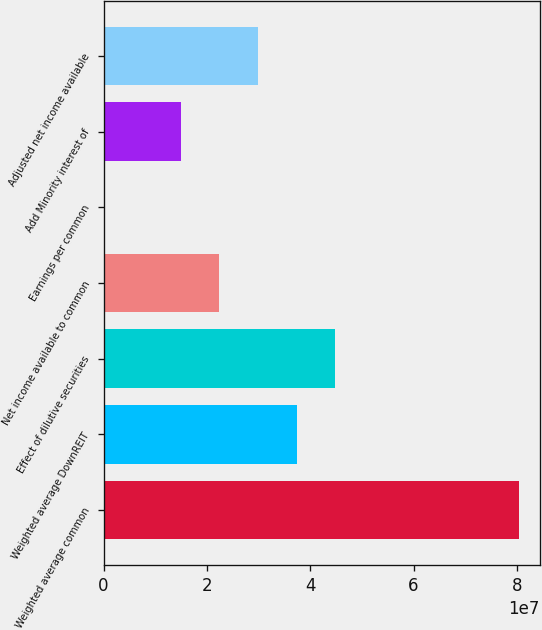Convert chart to OTSL. <chart><loc_0><loc_0><loc_500><loc_500><bar_chart><fcel>Weighted average common<fcel>Weighted average DownREIT<fcel>Effect of dilutive securities<fcel>Net income available to common<fcel>Earnings per common<fcel>Add Minority interest of<fcel>Adjusted net income available<nl><fcel>8.04284e+07<fcel>3.73797e+07<fcel>4.48556e+07<fcel>2.24278e+07<fcel>4.05<fcel>1.49519e+07<fcel>2.99037e+07<nl></chart> 